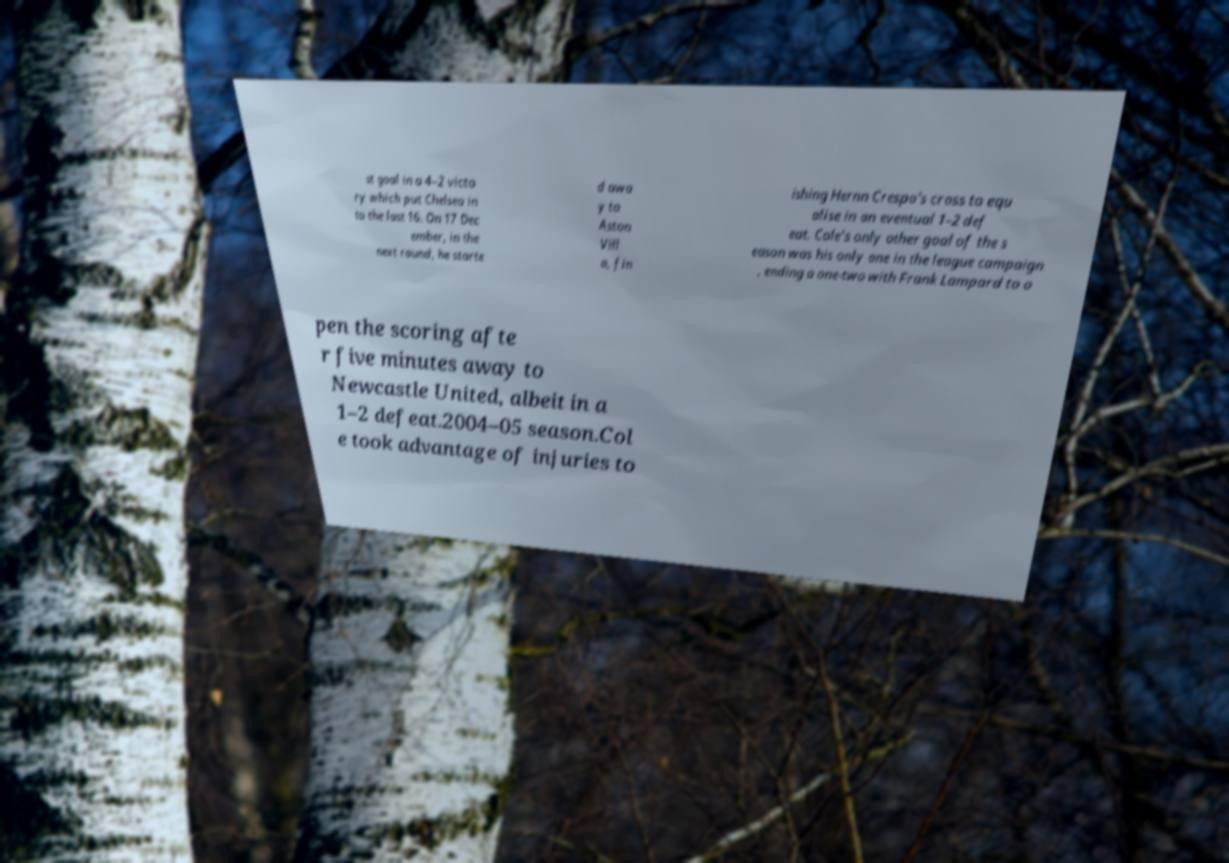Could you extract and type out the text from this image? st goal in a 4–2 victo ry which put Chelsea in to the last 16. On 17 Dec ember, in the next round, he starte d awa y to Aston Vill a, fin ishing Hernn Crespo's cross to equ alise in an eventual 1–2 def eat. Cole's only other goal of the s eason was his only one in the league campaign , ending a one-two with Frank Lampard to o pen the scoring afte r five minutes away to Newcastle United, albeit in a 1–2 defeat.2004–05 season.Col e took advantage of injuries to 